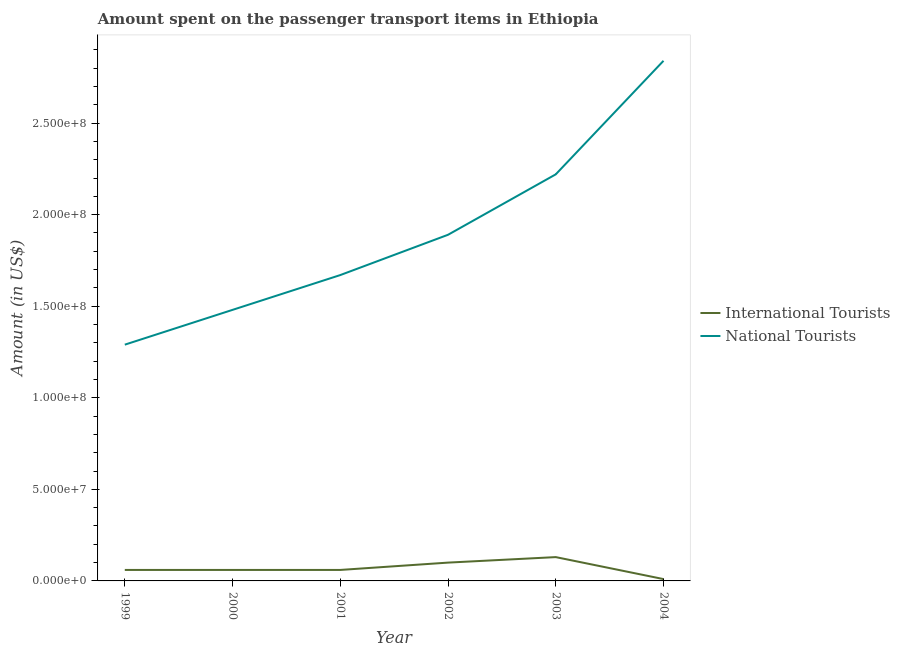Does the line corresponding to amount spent on transport items of international tourists intersect with the line corresponding to amount spent on transport items of national tourists?
Keep it short and to the point. No. Is the number of lines equal to the number of legend labels?
Ensure brevity in your answer.  Yes. What is the amount spent on transport items of international tourists in 2004?
Offer a very short reply. 1.00e+06. Across all years, what is the maximum amount spent on transport items of national tourists?
Keep it short and to the point. 2.84e+08. Across all years, what is the minimum amount spent on transport items of national tourists?
Offer a terse response. 1.29e+08. In which year was the amount spent on transport items of international tourists maximum?
Ensure brevity in your answer.  2003. What is the total amount spent on transport items of international tourists in the graph?
Keep it short and to the point. 4.20e+07. What is the difference between the amount spent on transport items of national tourists in 2003 and that in 2004?
Make the answer very short. -6.20e+07. What is the difference between the amount spent on transport items of national tourists in 1999 and the amount spent on transport items of international tourists in 2004?
Provide a short and direct response. 1.28e+08. In the year 2004, what is the difference between the amount spent on transport items of national tourists and amount spent on transport items of international tourists?
Offer a terse response. 2.83e+08. What is the ratio of the amount spent on transport items of national tourists in 2000 to that in 2001?
Ensure brevity in your answer.  0.89. Is the difference between the amount spent on transport items of national tourists in 1999 and 2003 greater than the difference between the amount spent on transport items of international tourists in 1999 and 2003?
Provide a short and direct response. No. What is the difference between the highest and the second highest amount spent on transport items of national tourists?
Provide a succinct answer. 6.20e+07. What is the difference between the highest and the lowest amount spent on transport items of international tourists?
Ensure brevity in your answer.  1.20e+07. In how many years, is the amount spent on transport items of international tourists greater than the average amount spent on transport items of international tourists taken over all years?
Provide a succinct answer. 2. Is the sum of the amount spent on transport items of international tourists in 2002 and 2003 greater than the maximum amount spent on transport items of national tourists across all years?
Your response must be concise. No. What is the difference between two consecutive major ticks on the Y-axis?
Keep it short and to the point. 5.00e+07. Are the values on the major ticks of Y-axis written in scientific E-notation?
Offer a very short reply. Yes. Does the graph contain any zero values?
Provide a short and direct response. No. Where does the legend appear in the graph?
Your response must be concise. Center right. How are the legend labels stacked?
Provide a short and direct response. Vertical. What is the title of the graph?
Your answer should be compact. Amount spent on the passenger transport items in Ethiopia. Does "current US$" appear as one of the legend labels in the graph?
Make the answer very short. No. What is the Amount (in US$) of National Tourists in 1999?
Make the answer very short. 1.29e+08. What is the Amount (in US$) in International Tourists in 2000?
Your response must be concise. 6.00e+06. What is the Amount (in US$) of National Tourists in 2000?
Provide a short and direct response. 1.48e+08. What is the Amount (in US$) of International Tourists in 2001?
Your answer should be very brief. 6.00e+06. What is the Amount (in US$) in National Tourists in 2001?
Provide a succinct answer. 1.67e+08. What is the Amount (in US$) of International Tourists in 2002?
Provide a succinct answer. 1.00e+07. What is the Amount (in US$) of National Tourists in 2002?
Offer a very short reply. 1.89e+08. What is the Amount (in US$) in International Tourists in 2003?
Your answer should be very brief. 1.30e+07. What is the Amount (in US$) of National Tourists in 2003?
Your answer should be compact. 2.22e+08. What is the Amount (in US$) in International Tourists in 2004?
Ensure brevity in your answer.  1.00e+06. What is the Amount (in US$) of National Tourists in 2004?
Offer a very short reply. 2.84e+08. Across all years, what is the maximum Amount (in US$) in International Tourists?
Keep it short and to the point. 1.30e+07. Across all years, what is the maximum Amount (in US$) in National Tourists?
Your answer should be very brief. 2.84e+08. Across all years, what is the minimum Amount (in US$) of National Tourists?
Your answer should be compact. 1.29e+08. What is the total Amount (in US$) in International Tourists in the graph?
Ensure brevity in your answer.  4.20e+07. What is the total Amount (in US$) of National Tourists in the graph?
Provide a succinct answer. 1.14e+09. What is the difference between the Amount (in US$) of International Tourists in 1999 and that in 2000?
Make the answer very short. 0. What is the difference between the Amount (in US$) in National Tourists in 1999 and that in 2000?
Your response must be concise. -1.90e+07. What is the difference between the Amount (in US$) in National Tourists in 1999 and that in 2001?
Offer a very short reply. -3.80e+07. What is the difference between the Amount (in US$) in National Tourists in 1999 and that in 2002?
Offer a terse response. -6.00e+07. What is the difference between the Amount (in US$) of International Tourists in 1999 and that in 2003?
Give a very brief answer. -7.00e+06. What is the difference between the Amount (in US$) in National Tourists in 1999 and that in 2003?
Offer a terse response. -9.30e+07. What is the difference between the Amount (in US$) of International Tourists in 1999 and that in 2004?
Give a very brief answer. 5.00e+06. What is the difference between the Amount (in US$) of National Tourists in 1999 and that in 2004?
Keep it short and to the point. -1.55e+08. What is the difference between the Amount (in US$) in National Tourists in 2000 and that in 2001?
Keep it short and to the point. -1.90e+07. What is the difference between the Amount (in US$) in National Tourists in 2000 and that in 2002?
Ensure brevity in your answer.  -4.10e+07. What is the difference between the Amount (in US$) of International Tourists in 2000 and that in 2003?
Your answer should be very brief. -7.00e+06. What is the difference between the Amount (in US$) in National Tourists in 2000 and that in 2003?
Ensure brevity in your answer.  -7.40e+07. What is the difference between the Amount (in US$) in International Tourists in 2000 and that in 2004?
Your answer should be compact. 5.00e+06. What is the difference between the Amount (in US$) in National Tourists in 2000 and that in 2004?
Your response must be concise. -1.36e+08. What is the difference between the Amount (in US$) of International Tourists in 2001 and that in 2002?
Your answer should be very brief. -4.00e+06. What is the difference between the Amount (in US$) of National Tourists in 2001 and that in 2002?
Offer a terse response. -2.20e+07. What is the difference between the Amount (in US$) in International Tourists in 2001 and that in 2003?
Provide a succinct answer. -7.00e+06. What is the difference between the Amount (in US$) of National Tourists in 2001 and that in 2003?
Provide a short and direct response. -5.50e+07. What is the difference between the Amount (in US$) in National Tourists in 2001 and that in 2004?
Make the answer very short. -1.17e+08. What is the difference between the Amount (in US$) in International Tourists in 2002 and that in 2003?
Provide a succinct answer. -3.00e+06. What is the difference between the Amount (in US$) in National Tourists in 2002 and that in 2003?
Ensure brevity in your answer.  -3.30e+07. What is the difference between the Amount (in US$) in International Tourists in 2002 and that in 2004?
Provide a succinct answer. 9.00e+06. What is the difference between the Amount (in US$) in National Tourists in 2002 and that in 2004?
Provide a succinct answer. -9.50e+07. What is the difference between the Amount (in US$) of International Tourists in 2003 and that in 2004?
Give a very brief answer. 1.20e+07. What is the difference between the Amount (in US$) of National Tourists in 2003 and that in 2004?
Provide a short and direct response. -6.20e+07. What is the difference between the Amount (in US$) of International Tourists in 1999 and the Amount (in US$) of National Tourists in 2000?
Give a very brief answer. -1.42e+08. What is the difference between the Amount (in US$) in International Tourists in 1999 and the Amount (in US$) in National Tourists in 2001?
Offer a very short reply. -1.61e+08. What is the difference between the Amount (in US$) in International Tourists in 1999 and the Amount (in US$) in National Tourists in 2002?
Ensure brevity in your answer.  -1.83e+08. What is the difference between the Amount (in US$) in International Tourists in 1999 and the Amount (in US$) in National Tourists in 2003?
Your answer should be very brief. -2.16e+08. What is the difference between the Amount (in US$) in International Tourists in 1999 and the Amount (in US$) in National Tourists in 2004?
Offer a terse response. -2.78e+08. What is the difference between the Amount (in US$) in International Tourists in 2000 and the Amount (in US$) in National Tourists in 2001?
Provide a short and direct response. -1.61e+08. What is the difference between the Amount (in US$) in International Tourists in 2000 and the Amount (in US$) in National Tourists in 2002?
Make the answer very short. -1.83e+08. What is the difference between the Amount (in US$) in International Tourists in 2000 and the Amount (in US$) in National Tourists in 2003?
Provide a short and direct response. -2.16e+08. What is the difference between the Amount (in US$) in International Tourists in 2000 and the Amount (in US$) in National Tourists in 2004?
Offer a terse response. -2.78e+08. What is the difference between the Amount (in US$) in International Tourists in 2001 and the Amount (in US$) in National Tourists in 2002?
Your answer should be compact. -1.83e+08. What is the difference between the Amount (in US$) in International Tourists in 2001 and the Amount (in US$) in National Tourists in 2003?
Provide a succinct answer. -2.16e+08. What is the difference between the Amount (in US$) in International Tourists in 2001 and the Amount (in US$) in National Tourists in 2004?
Offer a very short reply. -2.78e+08. What is the difference between the Amount (in US$) of International Tourists in 2002 and the Amount (in US$) of National Tourists in 2003?
Your response must be concise. -2.12e+08. What is the difference between the Amount (in US$) of International Tourists in 2002 and the Amount (in US$) of National Tourists in 2004?
Your response must be concise. -2.74e+08. What is the difference between the Amount (in US$) of International Tourists in 2003 and the Amount (in US$) of National Tourists in 2004?
Make the answer very short. -2.71e+08. What is the average Amount (in US$) of National Tourists per year?
Your answer should be very brief. 1.90e+08. In the year 1999, what is the difference between the Amount (in US$) in International Tourists and Amount (in US$) in National Tourists?
Offer a very short reply. -1.23e+08. In the year 2000, what is the difference between the Amount (in US$) in International Tourists and Amount (in US$) in National Tourists?
Provide a succinct answer. -1.42e+08. In the year 2001, what is the difference between the Amount (in US$) in International Tourists and Amount (in US$) in National Tourists?
Your answer should be very brief. -1.61e+08. In the year 2002, what is the difference between the Amount (in US$) in International Tourists and Amount (in US$) in National Tourists?
Give a very brief answer. -1.79e+08. In the year 2003, what is the difference between the Amount (in US$) in International Tourists and Amount (in US$) in National Tourists?
Your answer should be very brief. -2.09e+08. In the year 2004, what is the difference between the Amount (in US$) of International Tourists and Amount (in US$) of National Tourists?
Keep it short and to the point. -2.83e+08. What is the ratio of the Amount (in US$) of National Tourists in 1999 to that in 2000?
Keep it short and to the point. 0.87. What is the ratio of the Amount (in US$) in National Tourists in 1999 to that in 2001?
Keep it short and to the point. 0.77. What is the ratio of the Amount (in US$) of International Tourists in 1999 to that in 2002?
Your response must be concise. 0.6. What is the ratio of the Amount (in US$) of National Tourists in 1999 to that in 2002?
Your response must be concise. 0.68. What is the ratio of the Amount (in US$) in International Tourists in 1999 to that in 2003?
Offer a terse response. 0.46. What is the ratio of the Amount (in US$) in National Tourists in 1999 to that in 2003?
Keep it short and to the point. 0.58. What is the ratio of the Amount (in US$) of National Tourists in 1999 to that in 2004?
Make the answer very short. 0.45. What is the ratio of the Amount (in US$) in International Tourists in 2000 to that in 2001?
Offer a terse response. 1. What is the ratio of the Amount (in US$) of National Tourists in 2000 to that in 2001?
Your answer should be very brief. 0.89. What is the ratio of the Amount (in US$) of International Tourists in 2000 to that in 2002?
Your response must be concise. 0.6. What is the ratio of the Amount (in US$) in National Tourists in 2000 to that in 2002?
Offer a very short reply. 0.78. What is the ratio of the Amount (in US$) in International Tourists in 2000 to that in 2003?
Offer a terse response. 0.46. What is the ratio of the Amount (in US$) in National Tourists in 2000 to that in 2004?
Give a very brief answer. 0.52. What is the ratio of the Amount (in US$) in International Tourists in 2001 to that in 2002?
Keep it short and to the point. 0.6. What is the ratio of the Amount (in US$) of National Tourists in 2001 to that in 2002?
Make the answer very short. 0.88. What is the ratio of the Amount (in US$) of International Tourists in 2001 to that in 2003?
Give a very brief answer. 0.46. What is the ratio of the Amount (in US$) in National Tourists in 2001 to that in 2003?
Offer a very short reply. 0.75. What is the ratio of the Amount (in US$) in International Tourists in 2001 to that in 2004?
Offer a terse response. 6. What is the ratio of the Amount (in US$) in National Tourists in 2001 to that in 2004?
Offer a very short reply. 0.59. What is the ratio of the Amount (in US$) of International Tourists in 2002 to that in 2003?
Your response must be concise. 0.77. What is the ratio of the Amount (in US$) of National Tourists in 2002 to that in 2003?
Keep it short and to the point. 0.85. What is the ratio of the Amount (in US$) in National Tourists in 2002 to that in 2004?
Your response must be concise. 0.67. What is the ratio of the Amount (in US$) in International Tourists in 2003 to that in 2004?
Provide a succinct answer. 13. What is the ratio of the Amount (in US$) in National Tourists in 2003 to that in 2004?
Keep it short and to the point. 0.78. What is the difference between the highest and the second highest Amount (in US$) in National Tourists?
Make the answer very short. 6.20e+07. What is the difference between the highest and the lowest Amount (in US$) in National Tourists?
Your response must be concise. 1.55e+08. 